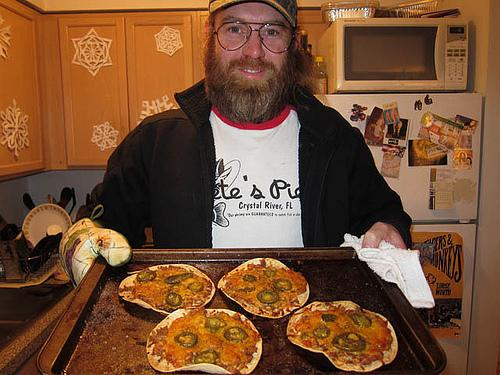How can you tell that this guy likes his food a little spicy? Please explain your reasoning. jalapenos. The man has jalapeno peppers on his tortillas. 